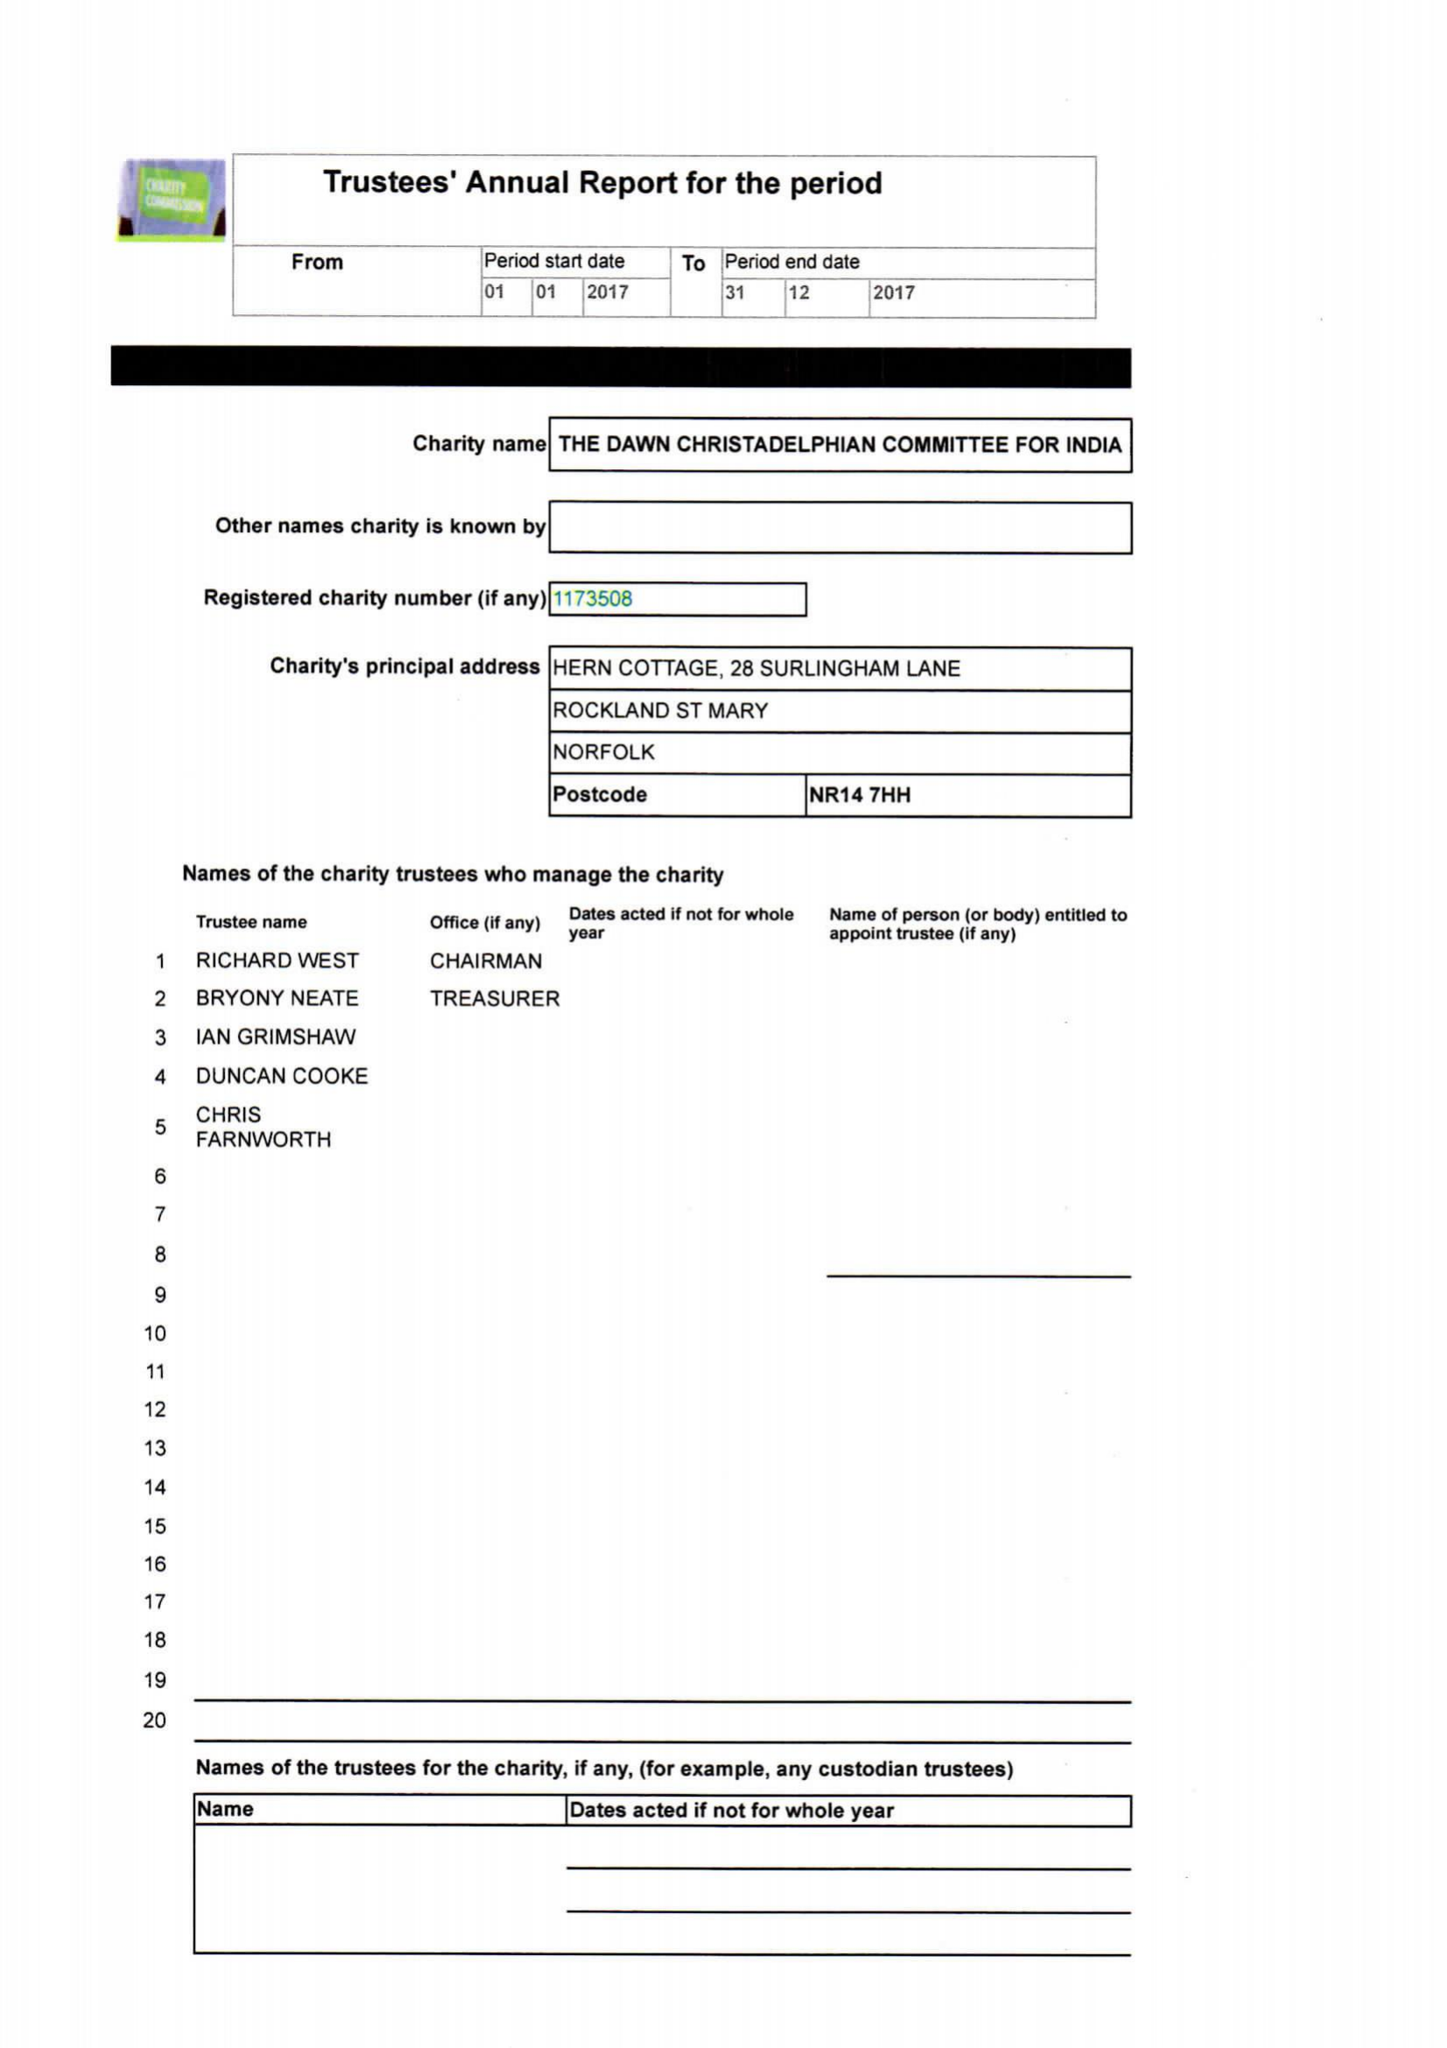What is the value for the address__postcode?
Answer the question using a single word or phrase. NR14 7HH 